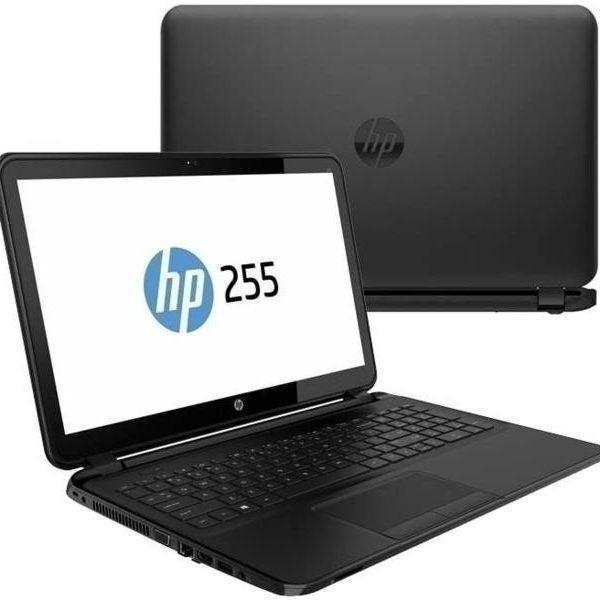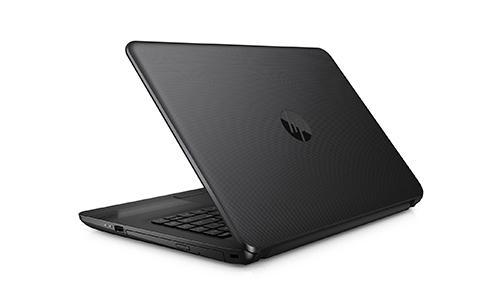The first image is the image on the left, the second image is the image on the right. For the images shown, is this caption "A laptop is turned so the screen is visible, and another laptop is turned so the back of the screen is visible." true? Answer yes or no. Yes. The first image is the image on the left, the second image is the image on the right. Assess this claim about the two images: "There is an open laptop with a white screen displayed that features a blue circular logo". Correct or not? Answer yes or no. Yes. 